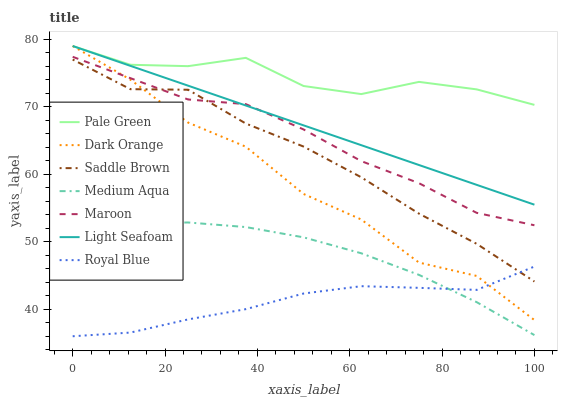Does Royal Blue have the minimum area under the curve?
Answer yes or no. Yes. Does Pale Green have the maximum area under the curve?
Answer yes or no. Yes. Does Maroon have the minimum area under the curve?
Answer yes or no. No. Does Maroon have the maximum area under the curve?
Answer yes or no. No. Is Light Seafoam the smoothest?
Answer yes or no. Yes. Is Dark Orange the roughest?
Answer yes or no. Yes. Is Maroon the smoothest?
Answer yes or no. No. Is Maroon the roughest?
Answer yes or no. No. Does Royal Blue have the lowest value?
Answer yes or no. Yes. Does Maroon have the lowest value?
Answer yes or no. No. Does Light Seafoam have the highest value?
Answer yes or no. Yes. Does Maroon have the highest value?
Answer yes or no. No. Is Maroon less than Pale Green?
Answer yes or no. Yes. Is Pale Green greater than Royal Blue?
Answer yes or no. Yes. Does Dark Orange intersect Pale Green?
Answer yes or no. Yes. Is Dark Orange less than Pale Green?
Answer yes or no. No. Is Dark Orange greater than Pale Green?
Answer yes or no. No. Does Maroon intersect Pale Green?
Answer yes or no. No. 